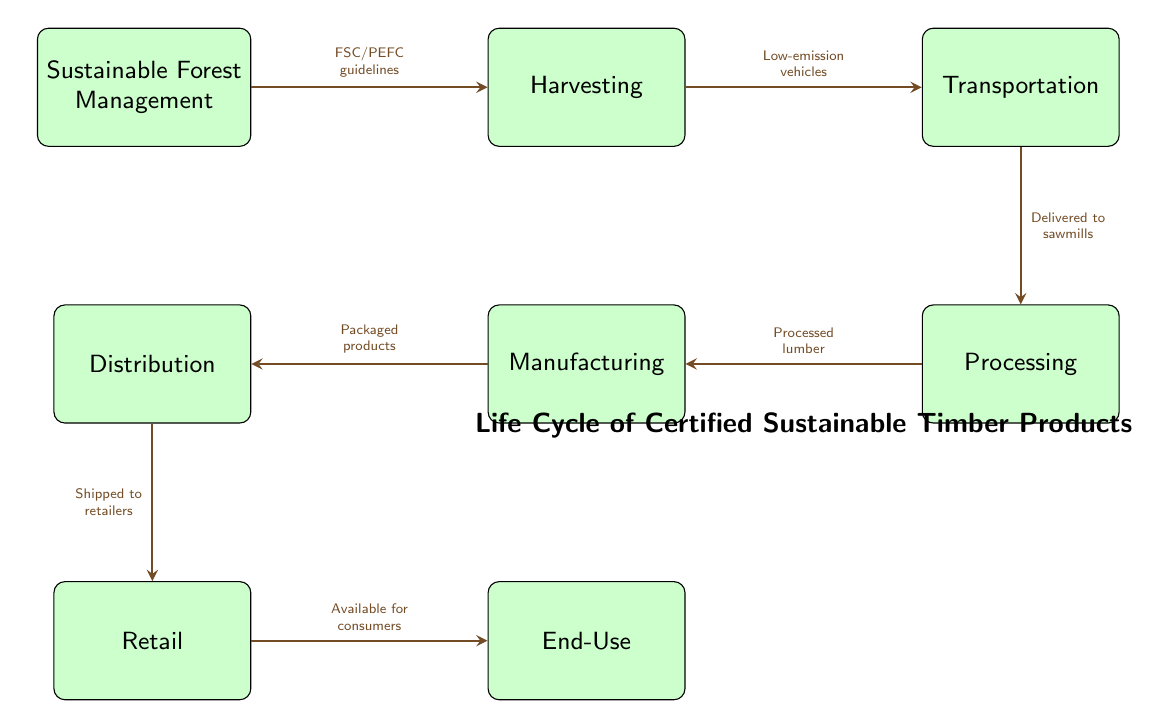What is the first step in the life cycle of certified sustainable timber products? The first step is indicated in the diagram as "Sustainable Forest Management," which is the starting point before any timber is harvested.
Answer: Sustainable Forest Management What comes after harvesting in the process? According to the diagram, the step that follows "Harvesting" is "Transportation," showing the flow from one process to the next.
Answer: Transportation How many total nodes are present in the diagram? By counting the labeled nodes in the diagram, there are 8 distinct steps or nodes outlined in the life cycle of certified sustainable timber products.
Answer: 8 What guidelines are referred to between sustainable forest management and harvesting? The diagram notes "FSC/PEFC guidelines" as the connecting relationship between "Sustainable Forest Management" and "Harvesting," indicating the standards that govern the initial process.
Answer: FSC/PEFC guidelines Which step immediately precedes retail in the diagram? Looking at the diagram, the step that comes right before "Retail" is "Distribution," demonstrating the flow of products before reaching the retail stage.
Answer: Distribution What type of vehicles is used for transportation according to the diagram? The diagram specifies "Low-emission vehicles" as the mode of transportation for delivering the harvested timber to subsequent processing facilities, highlighting a sustainable approach.
Answer: Low-emission vehicles What is the final stage of the life cycle depicted in the diagram? The last step in the life cycle, as shown in the diagram, is "End-Use," indicating where the timber products are utilized by consumers.
Answer: End-Use How are the timber products packaged before distribution? "Packaged products" is the term used in the diagram for the state of timber products before they are distributed to retailers, indicating the form they take at that stage.
Answer: Packaged products What is the relationship between processing and manufacturing? The diagram indicates that processed lumber moves from "Processing" to "Manufacturing," illustrating the transition from raw materials to finished goods.
Answer: Processed lumber 